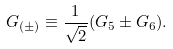Convert formula to latex. <formula><loc_0><loc_0><loc_500><loc_500>G _ { ( \pm ) } \equiv \frac { 1 } { \sqrt { 2 } } ( G _ { 5 } \pm G _ { 6 } ) .</formula> 